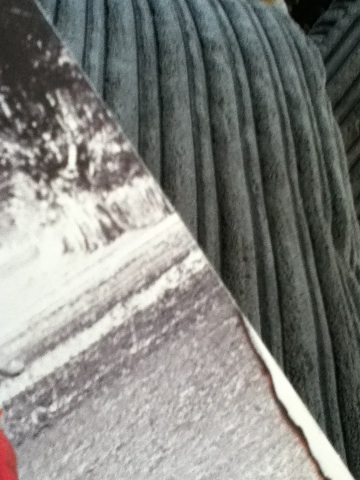Can you tell me something about the design or texture on the cover of this book? The cover of the book features a textured design that resembles ridges or grooves, which might suggest an artistic or thematic element related to the content within. For instance, such a design could be symbolic of landscapes, paths, or journeys which are themes often found in literature. Without additional context, it is speculative, but the design choice is likely intentional and could be an intriguing visual clue about the book's narrative. 